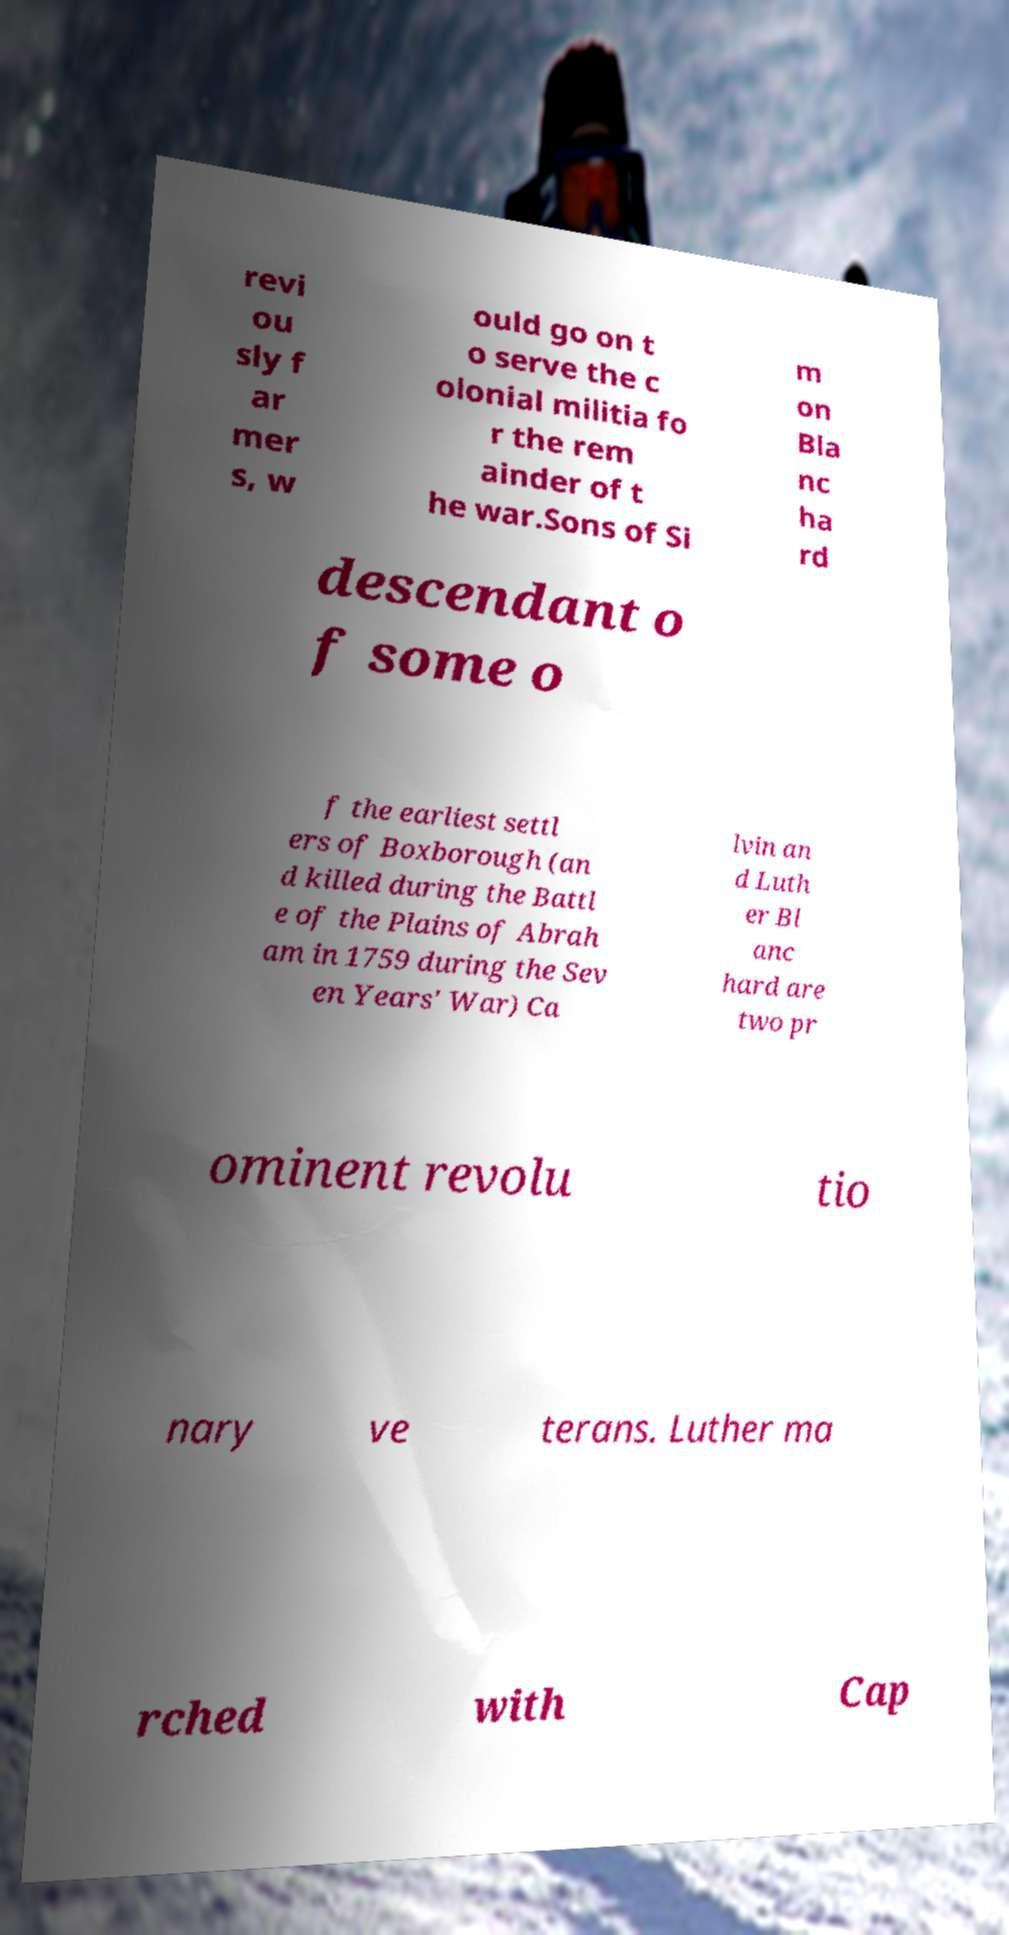I need the written content from this picture converted into text. Can you do that? revi ou sly f ar mer s, w ould go on t o serve the c olonial militia fo r the rem ainder of t he war.Sons of Si m on Bla nc ha rd descendant o f some o f the earliest settl ers of Boxborough (an d killed during the Battl e of the Plains of Abrah am in 1759 during the Sev en Years' War) Ca lvin an d Luth er Bl anc hard are two pr ominent revolu tio nary ve terans. Luther ma rched with Cap 